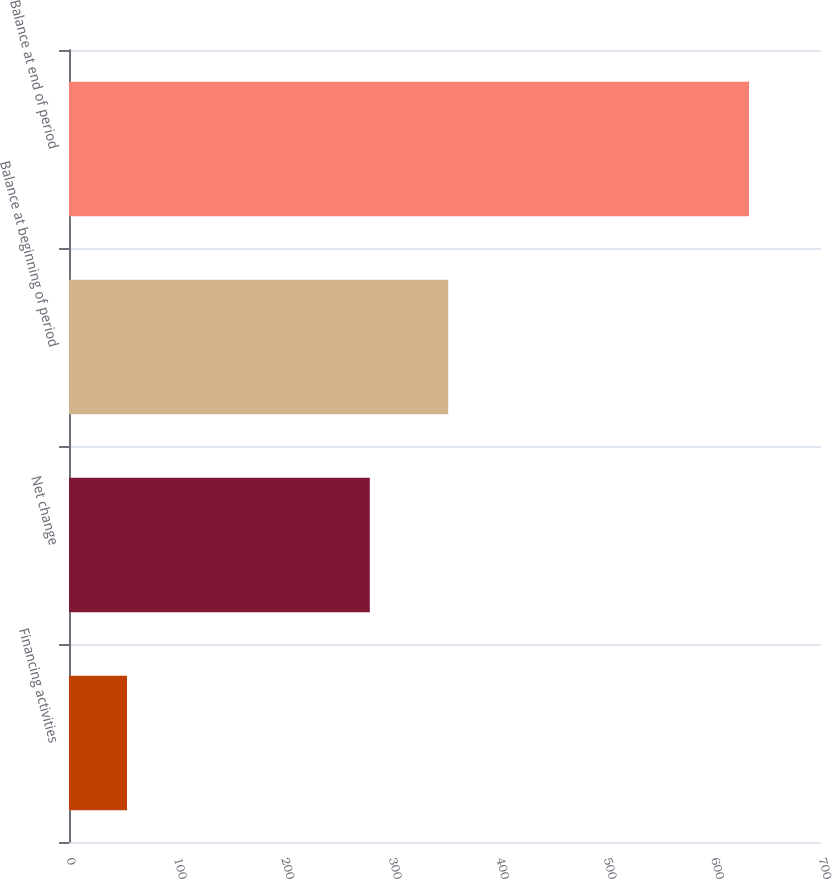<chart> <loc_0><loc_0><loc_500><loc_500><bar_chart><fcel>Financing activities<fcel>Net change<fcel>Balance at beginning of period<fcel>Balance at end of period<nl><fcel>54<fcel>280<fcel>353<fcel>633<nl></chart> 